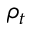Convert formula to latex. <formula><loc_0><loc_0><loc_500><loc_500>\rho _ { t }</formula> 